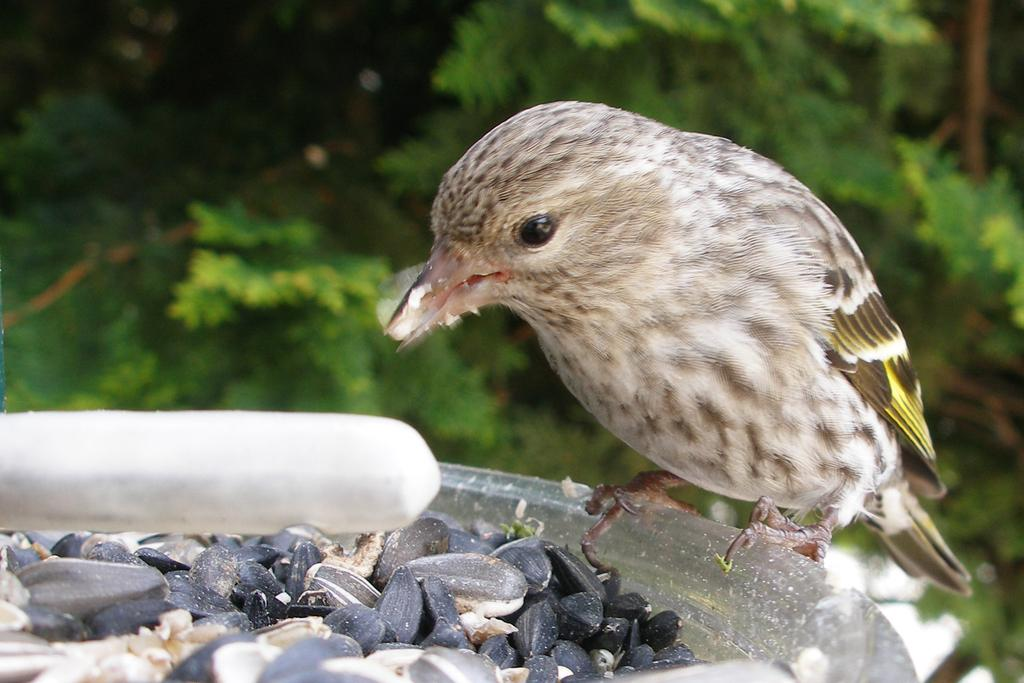What is the main subject in the foreground of the image? There is a bird in the foreground of the image. What is the bird doing in the image? The bird is sitting on an object. What type of food can be seen in the image? Sunflower seeds are visible in the image. What can be seen in the background of the image? There are trees in the background of the image. When do you think the image was taken? The image was likely taken during the day, as the sun is not visible. What type of song is the bird singing in the image? There is no indication that the bird is singing in the image. What joke is the bird telling in the image? Birds do not tell jokes, and there is no indication of any joke being told in the image. 